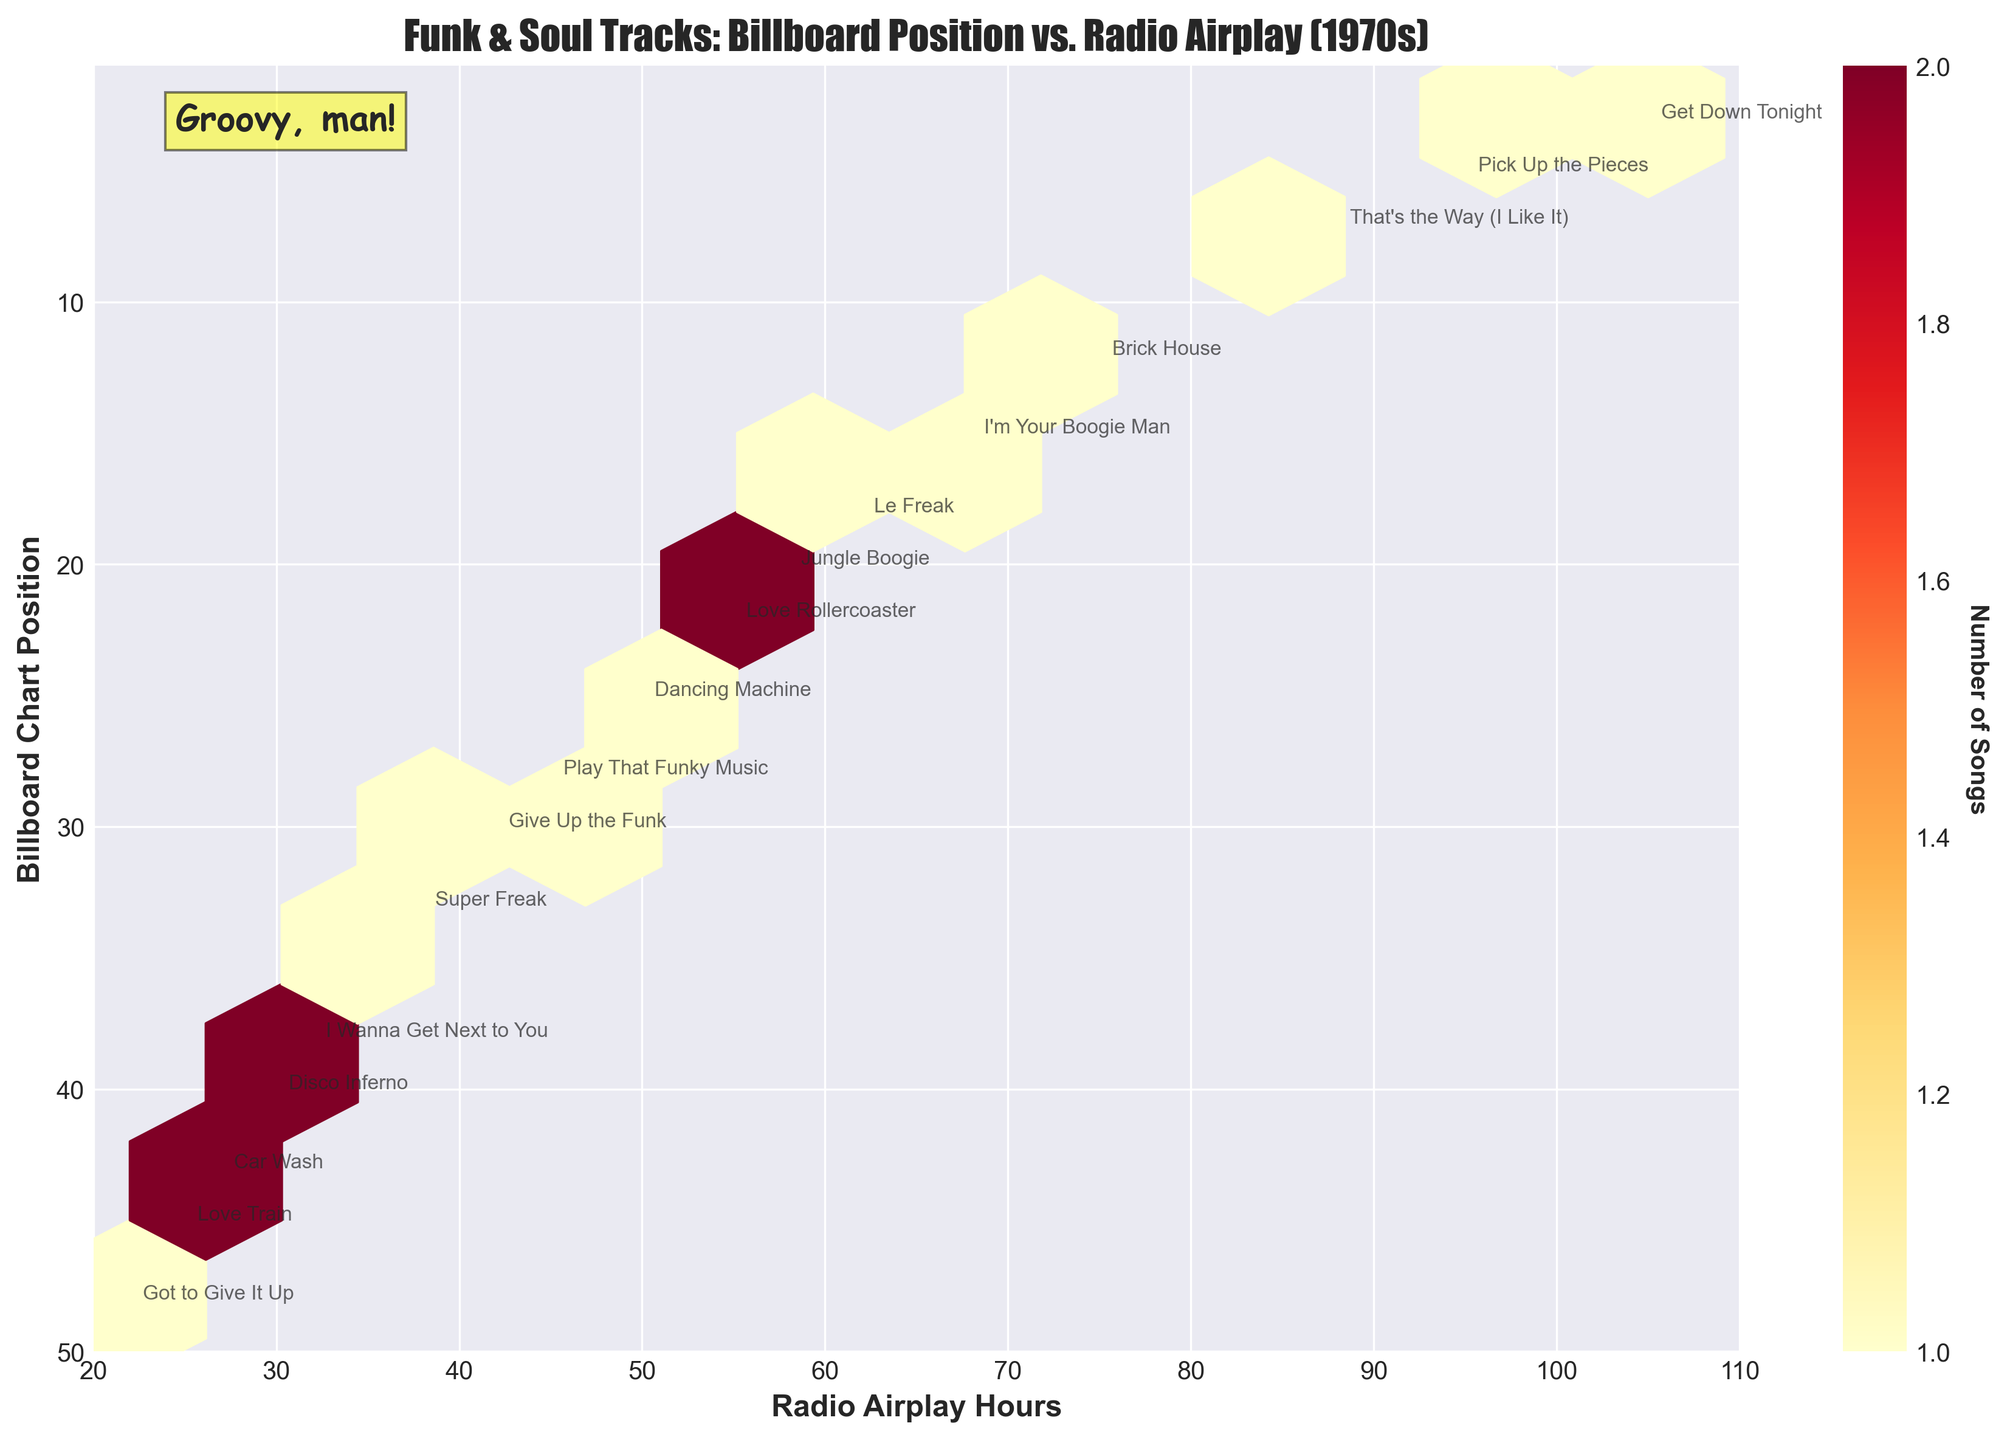What is the title of the hexbin plot? The title is located at the top of the figure and often provides an overview of what the plot is about. Here, it describes the subject of the visualization.
Answer: Funk & Soul Tracks: Billboard Position vs. Radio Airplay (1970s) What are the labels of the axes in the plot? Axis labels are usually found along the bottom and the side of the plot. They indicate what each axis represents.
Answer: Radio Airplay Hours and Billboard Chart Position How are the colors in the hexbin plot assigned? The color in a hexbin plot typically represents the density of data points within each hexagon. The color bar on the right of the plot shows this relationship.
Answer: Density of Songs Which area of the plot has the highest concentration of funk and soul tracks? The area with the darkest color denotes the highest concentration of data points (songs).
Answer: Top-right corner (near high radio airplay hours and lower chart positions) How many songs have more than 90 radio airplay hours? To answer this, identify each hexagon that corresponds to over 90 airplay hours and count the songs.
Answer: 2 songs What's the range of the Billboard Chart Positions shown in the plot? The axis range will show the span covered by the available data points. Here, the y-axis range determines this.
Answer: 1 to 50 Is there a song labeled "Jungle Boogie" present in the plot? If yes, what are its coordinates? Look for the specific annotation "Jungle Boogie" in the plot to find its coordinates.
Answer: Yes, (58, 20) Which song had the lowest radio airplay hours but still made it to the charts? To find this, locate the data point with the smallest x-value (radio airplay hours).
Answer: Got to Give It Up (22 hours) What is the color of the hexagon that contains the most songs? Observe the color scale and find the darkest hexagon, then report its color.
Answer: Dark red How does the chart position relate to radio airplay hours in the 1970s for funk and soul tracks based on the plot? The relationship can be seen in the distribution pattern of the hexagons, with more airplay generally leading to better chart positions (lower position numbers).
Answer: Inverse relationship; more airplay tends to result in better chart positions 